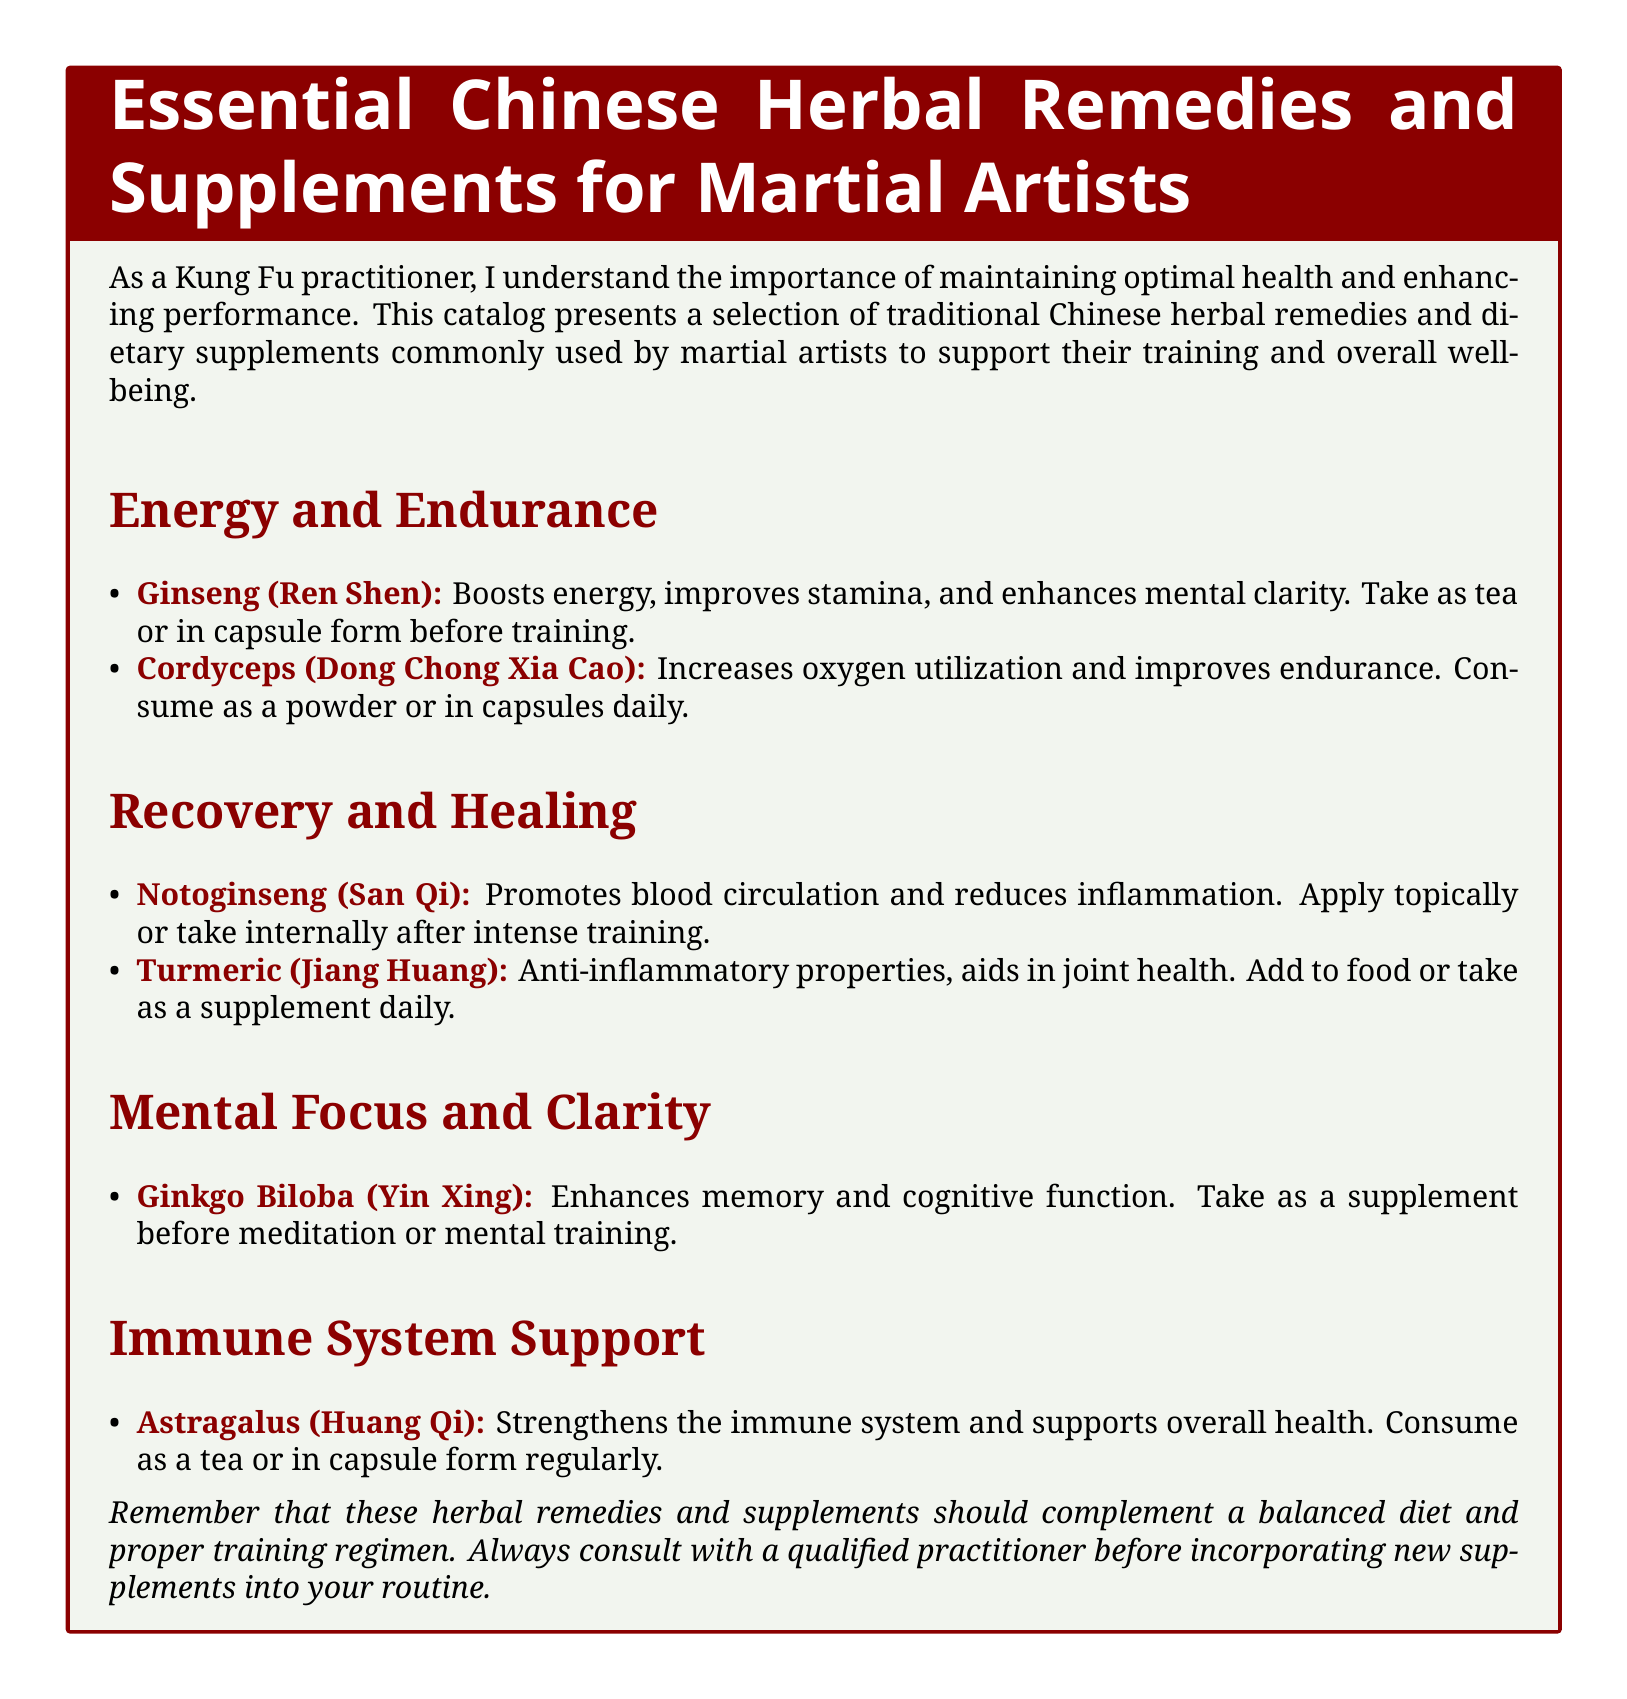What is a benefit of Ginseng? Ginseng boosts energy, improves stamina, and enhances mental clarity according to the document.
Answer: Boosts energy What should Notoginseng be used for? Notoginseng promotes blood circulation and reduces inflammation as stated in the catalog.
Answer: Recovery How can you consume Cordyceps? The document specifies that Cordyceps can be consumed as a powder or in capsules.
Answer: Powder or capsules What is the main purpose of Astragalus? Astragalus strengthens the immune system and supports overall health according to the text.
Answer: Immune system support Which herb is mentioned for mental focus? The document lists Ginkgo Biloba specifically for enhancing memory and cognitive function.
Answer: Ginkgo Biloba What dietary action is recommended for Turmeric? The catalog suggests adding Turmeric to food or taking it as a supplement.
Answer: Add to food or take as a supplement What type of remedies does this catalog focus on? The catalog presents traditional Chinese herbal remedies and dietary supplements for martial artists.
Answer: Herbal remedies and dietary supplements How often should Ginkgo Biloba be taken? The document doesn’t specify a frequency, only that it should be taken before meditation or mental training.
Answer: Before meditation What is the color scheme used in the document? The document utilizes kungfured and bamboo colors for its design.
Answer: Kungfured and bamboo 